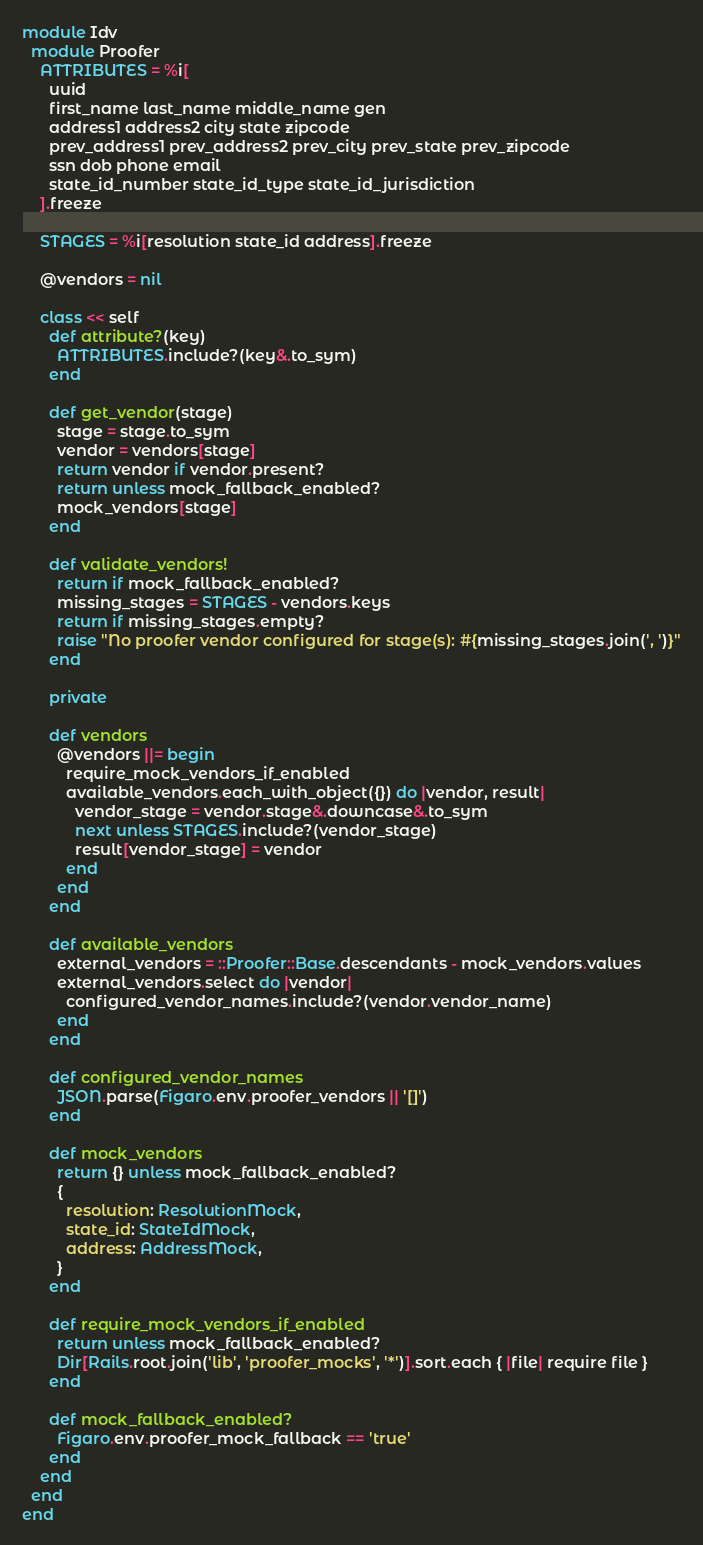Convert code to text. <code><loc_0><loc_0><loc_500><loc_500><_Ruby_>module Idv
  module Proofer
    ATTRIBUTES = %i[
      uuid
      first_name last_name middle_name gen
      address1 address2 city state zipcode
      prev_address1 prev_address2 prev_city prev_state prev_zipcode
      ssn dob phone email
      state_id_number state_id_type state_id_jurisdiction
    ].freeze

    STAGES = %i[resolution state_id address].freeze

    @vendors = nil

    class << self
      def attribute?(key)
        ATTRIBUTES.include?(key&.to_sym)
      end

      def get_vendor(stage)
        stage = stage.to_sym
        vendor = vendors[stage]
        return vendor if vendor.present?
        return unless mock_fallback_enabled?
        mock_vendors[stage]
      end

      def validate_vendors!
        return if mock_fallback_enabled?
        missing_stages = STAGES - vendors.keys
        return if missing_stages.empty?
        raise "No proofer vendor configured for stage(s): #{missing_stages.join(', ')}"
      end

      private

      def vendors
        @vendors ||= begin
          require_mock_vendors_if_enabled
          available_vendors.each_with_object({}) do |vendor, result|
            vendor_stage = vendor.stage&.downcase&.to_sym
            next unless STAGES.include?(vendor_stage)
            result[vendor_stage] = vendor
          end
        end
      end

      def available_vendors
        external_vendors = ::Proofer::Base.descendants - mock_vendors.values
        external_vendors.select do |vendor|
          configured_vendor_names.include?(vendor.vendor_name)
        end
      end

      def configured_vendor_names
        JSON.parse(Figaro.env.proofer_vendors || '[]')
      end

      def mock_vendors
        return {} unless mock_fallback_enabled?
        {
          resolution: ResolutionMock,
          state_id: StateIdMock,
          address: AddressMock,
        }
      end

      def require_mock_vendors_if_enabled
        return unless mock_fallback_enabled?
        Dir[Rails.root.join('lib', 'proofer_mocks', '*')].sort.each { |file| require file }
      end

      def mock_fallback_enabled?
        Figaro.env.proofer_mock_fallback == 'true'
      end
    end
  end
end
</code> 